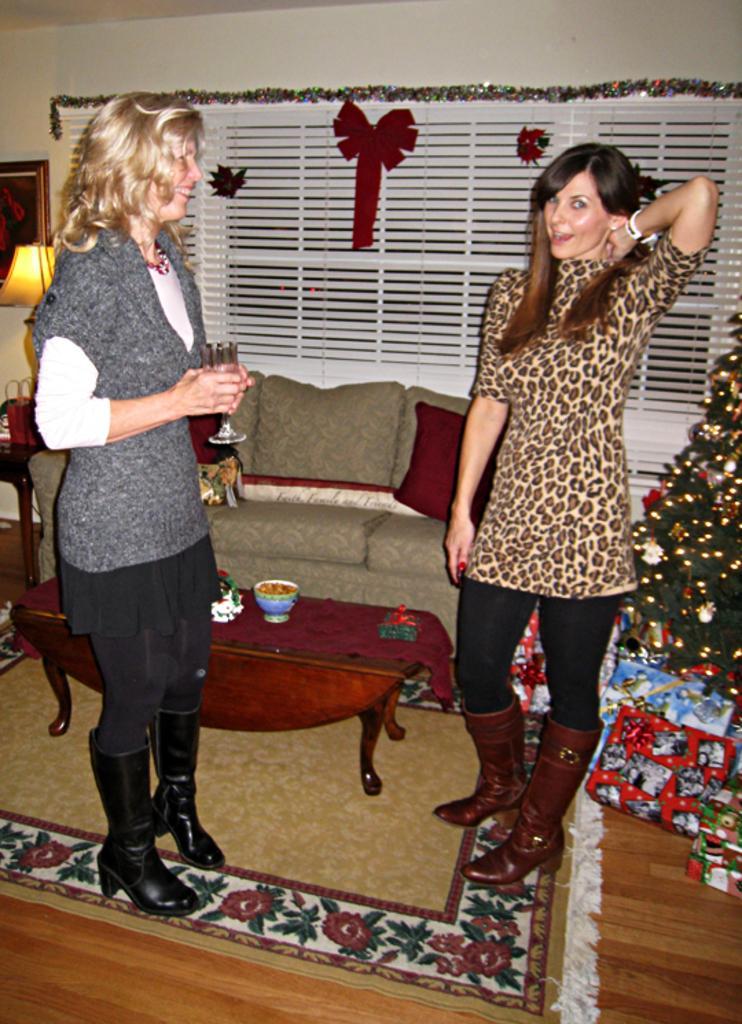Can you describe this image briefly? On the left side, there is a woman, smiling, holding a glass and standing on a mat which is on the floor. On the right side, there is a woman, smiling, placing one hand on her neck and standing. Beside her, there is a Christmas tree. In front of her, there is a table on which, there is a cup and other objects. In the background, there is a sofa, a light attached to the wall and there is a window. 